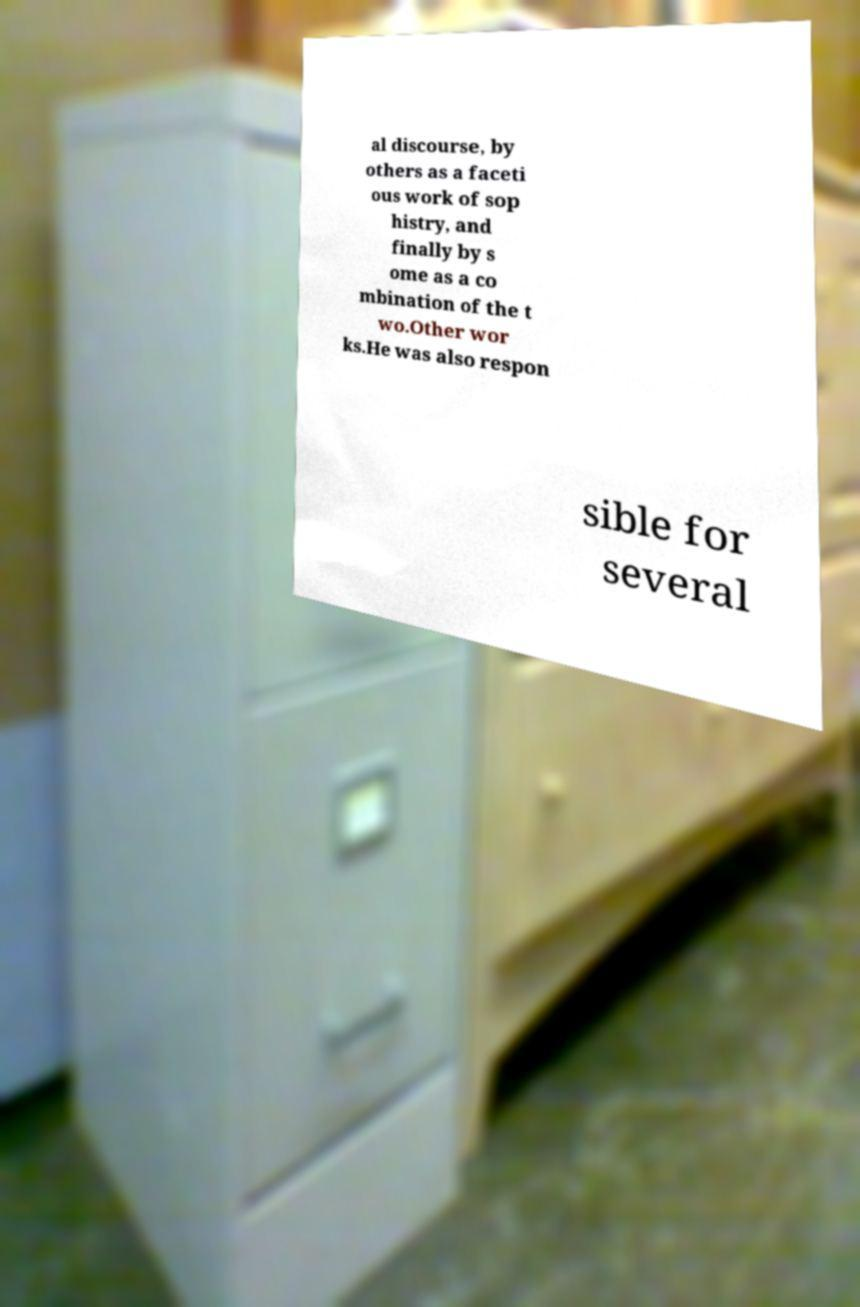I need the written content from this picture converted into text. Can you do that? al discourse, by others as a faceti ous work of sop histry, and finally by s ome as a co mbination of the t wo.Other wor ks.He was also respon sible for several 